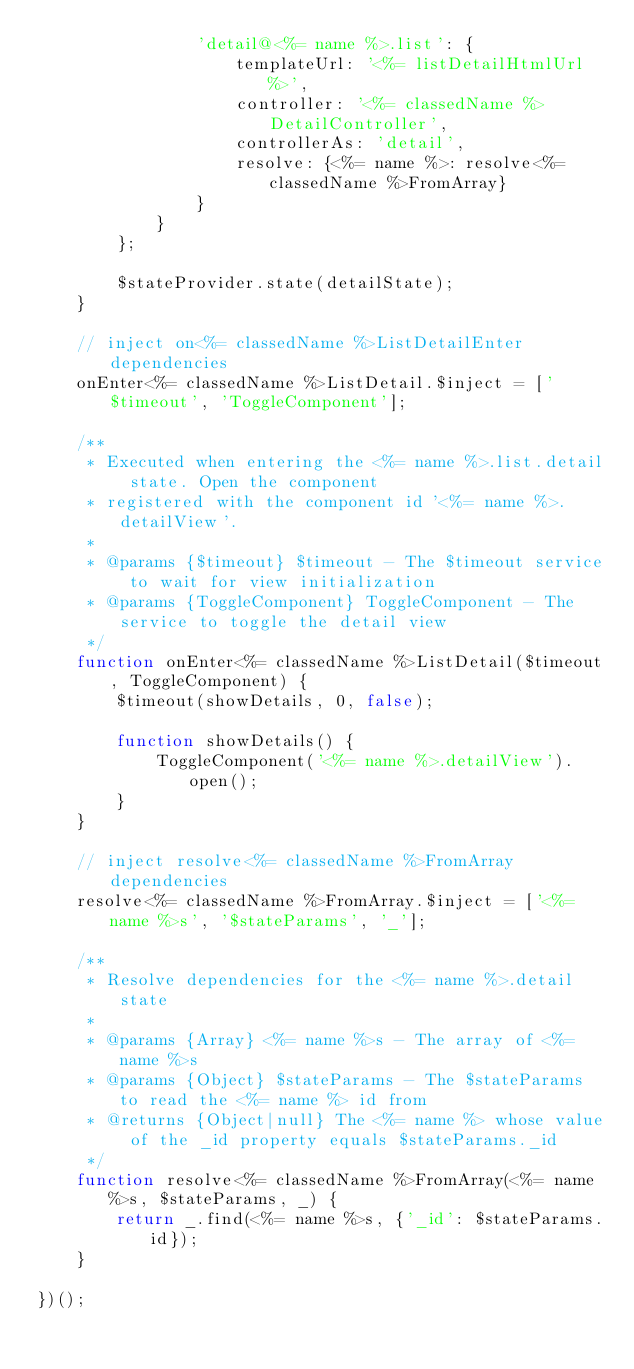<code> <loc_0><loc_0><loc_500><loc_500><_JavaScript_>				'detail@<%= name %>.list': {
					templateUrl: '<%= listDetailHtmlUrl %>',
					controller: '<%= classedName %>DetailController',
					controllerAs: 'detail',
					resolve: {<%= name %>: resolve<%= classedName %>FromArray}
				}
			}
		};

		$stateProvider.state(detailState);
	}

	// inject on<%= classedName %>ListDetailEnter dependencies
	onEnter<%= classedName %>ListDetail.$inject = ['$timeout', 'ToggleComponent'];

	/**
	 * Executed when entering the <%= name %>.list.detail state. Open the component
	 * registered with the component id '<%= name %>.detailView'.
	 *
 	 * @params {$timeout} $timeout - The $timeout service to wait for view initialization
	 * @params {ToggleComponent} ToggleComponent - The service to toggle the detail view
	 */
	function onEnter<%= classedName %>ListDetail($timeout, ToggleComponent) {
		$timeout(showDetails, 0, false);

		function showDetails() {
			ToggleComponent('<%= name %>.detailView').open();
		}
	}

	// inject resolve<%= classedName %>FromArray dependencies
	resolve<%= classedName %>FromArray.$inject = ['<%= name %>s', '$stateParams', '_'];

	/**
	 * Resolve dependencies for the <%= name %>.detail state
	 *
	 * @params {Array} <%= name %>s - The array of <%= name %>s
	 * @params {Object} $stateParams - The $stateParams to read the <%= name %> id from
	 * @returns {Object|null} The <%= name %> whose value of the _id property equals $stateParams._id
	 */
	function resolve<%= classedName %>FromArray(<%= name %>s, $stateParams, _) {
		return _.find(<%= name %>s, {'_id': $stateParams.id});
	}

})();
</code> 